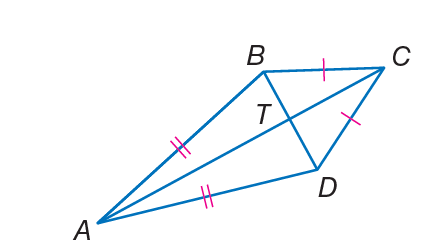Can you explain how to find angle ATB in the given kite figure? Certainly! To find angle ATB in the kite, you must remember that the consecutive angles between the unequal sides of a kite are supplementary, meaning they sum up to 180 degrees. Since we already know angle BAD is 38 degrees, angle ATB would be calculated as 180 degrees minus 38 degrees, resulting in angle ATB being 142 degrees. 